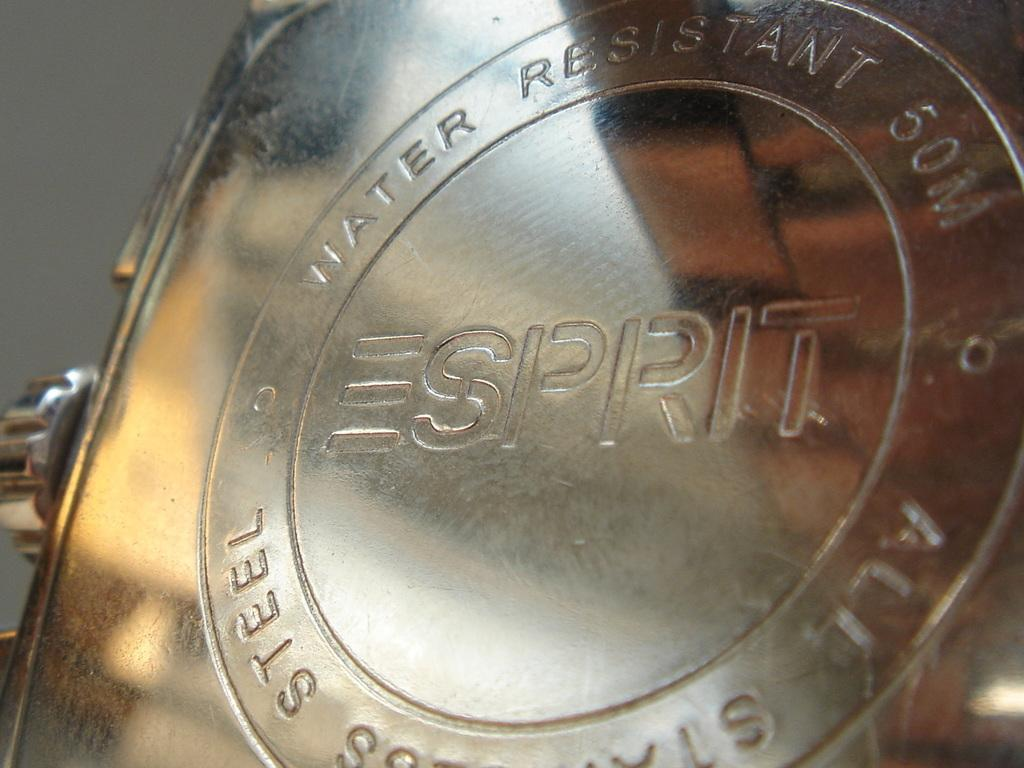<image>
Give a short and clear explanation of the subsequent image. The metal, stamped by the Esprit brand, is water-resistant. 